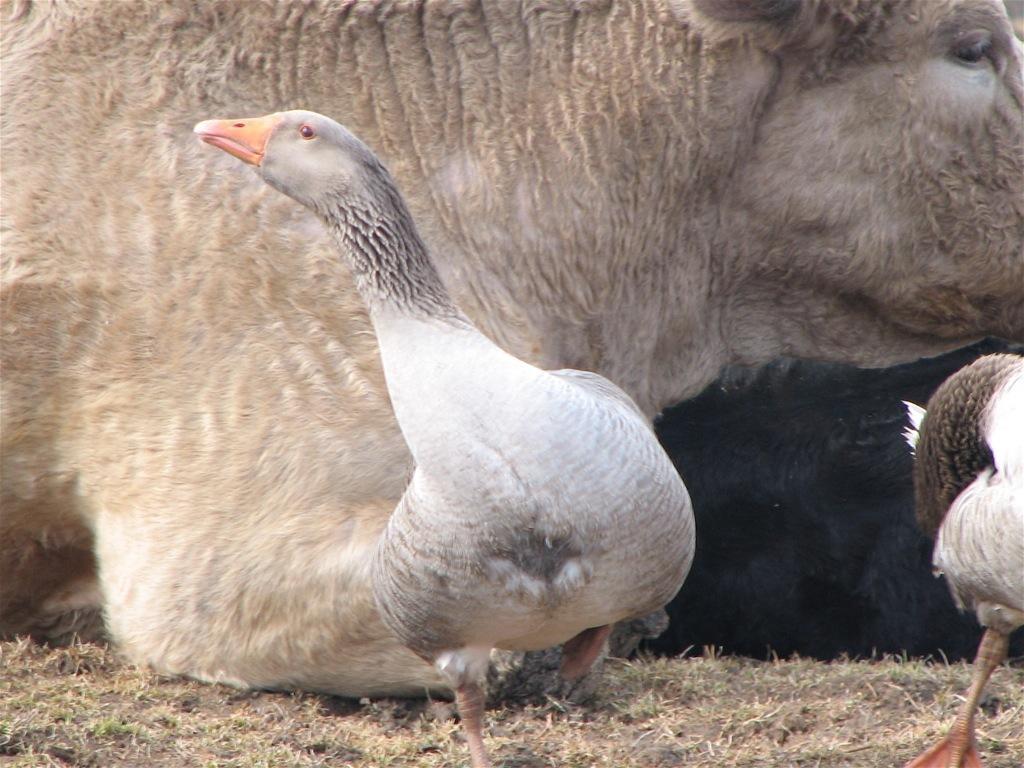Can you describe this image briefly? This picture shows a cow and it is light brown in color and ducks are white and black in color and we see grass on the ground. 